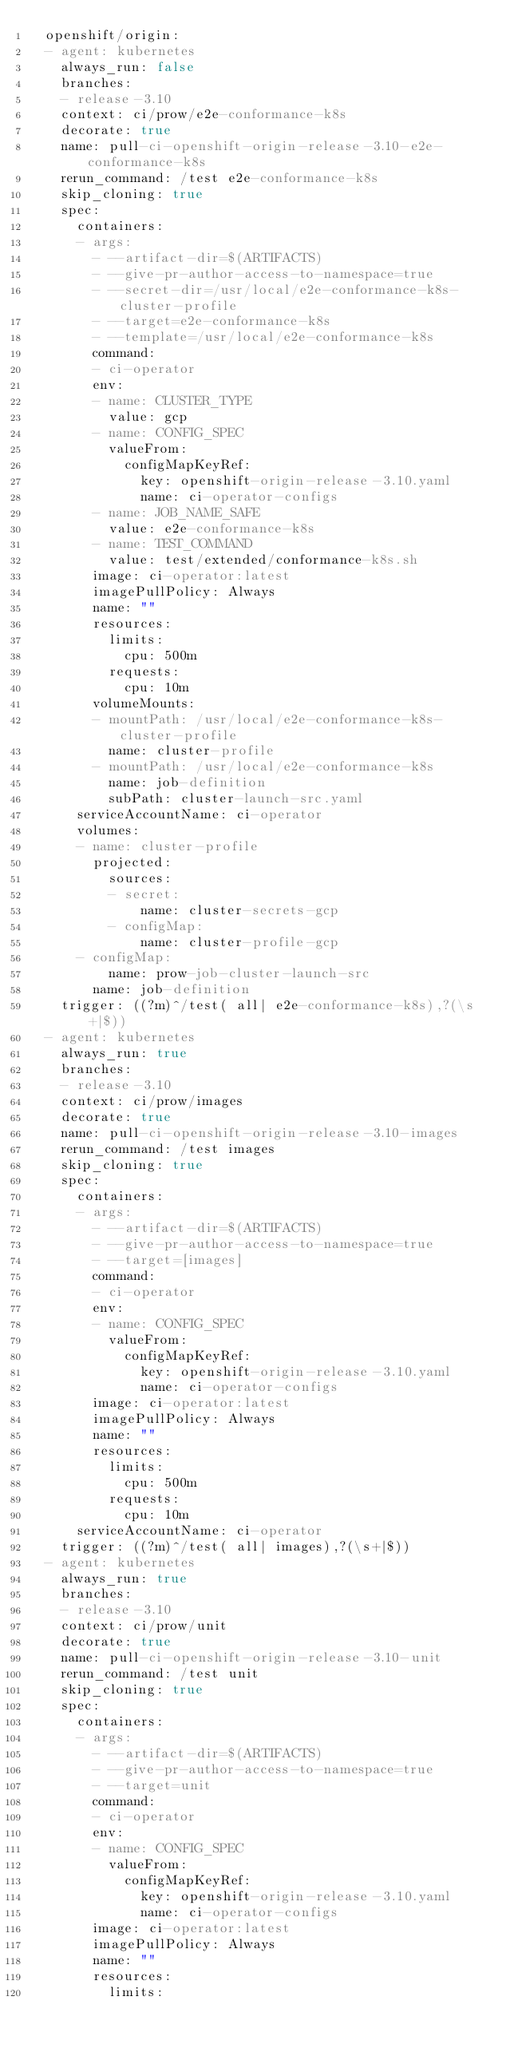<code> <loc_0><loc_0><loc_500><loc_500><_YAML_>  openshift/origin:
  - agent: kubernetes
    always_run: false
    branches:
    - release-3.10
    context: ci/prow/e2e-conformance-k8s
    decorate: true
    name: pull-ci-openshift-origin-release-3.10-e2e-conformance-k8s
    rerun_command: /test e2e-conformance-k8s
    skip_cloning: true
    spec:
      containers:
      - args:
        - --artifact-dir=$(ARTIFACTS)
        - --give-pr-author-access-to-namespace=true
        - --secret-dir=/usr/local/e2e-conformance-k8s-cluster-profile
        - --target=e2e-conformance-k8s
        - --template=/usr/local/e2e-conformance-k8s
        command:
        - ci-operator
        env:
        - name: CLUSTER_TYPE
          value: gcp
        - name: CONFIG_SPEC
          valueFrom:
            configMapKeyRef:
              key: openshift-origin-release-3.10.yaml
              name: ci-operator-configs
        - name: JOB_NAME_SAFE
          value: e2e-conformance-k8s
        - name: TEST_COMMAND
          value: test/extended/conformance-k8s.sh
        image: ci-operator:latest
        imagePullPolicy: Always
        name: ""
        resources:
          limits:
            cpu: 500m
          requests:
            cpu: 10m
        volumeMounts:
        - mountPath: /usr/local/e2e-conformance-k8s-cluster-profile
          name: cluster-profile
        - mountPath: /usr/local/e2e-conformance-k8s
          name: job-definition
          subPath: cluster-launch-src.yaml
      serviceAccountName: ci-operator
      volumes:
      - name: cluster-profile
        projected:
          sources:
          - secret:
              name: cluster-secrets-gcp
          - configMap:
              name: cluster-profile-gcp
      - configMap:
          name: prow-job-cluster-launch-src
        name: job-definition
    trigger: ((?m)^/test( all| e2e-conformance-k8s),?(\s+|$))
  - agent: kubernetes
    always_run: true
    branches:
    - release-3.10
    context: ci/prow/images
    decorate: true
    name: pull-ci-openshift-origin-release-3.10-images
    rerun_command: /test images
    skip_cloning: true
    spec:
      containers:
      - args:
        - --artifact-dir=$(ARTIFACTS)
        - --give-pr-author-access-to-namespace=true
        - --target=[images]
        command:
        - ci-operator
        env:
        - name: CONFIG_SPEC
          valueFrom:
            configMapKeyRef:
              key: openshift-origin-release-3.10.yaml
              name: ci-operator-configs
        image: ci-operator:latest
        imagePullPolicy: Always
        name: ""
        resources:
          limits:
            cpu: 500m
          requests:
            cpu: 10m
      serviceAccountName: ci-operator
    trigger: ((?m)^/test( all| images),?(\s+|$))
  - agent: kubernetes
    always_run: true
    branches:
    - release-3.10
    context: ci/prow/unit
    decorate: true
    name: pull-ci-openshift-origin-release-3.10-unit
    rerun_command: /test unit
    skip_cloning: true
    spec:
      containers:
      - args:
        - --artifact-dir=$(ARTIFACTS)
        - --give-pr-author-access-to-namespace=true
        - --target=unit
        command:
        - ci-operator
        env:
        - name: CONFIG_SPEC
          valueFrom:
            configMapKeyRef:
              key: openshift-origin-release-3.10.yaml
              name: ci-operator-configs
        image: ci-operator:latest
        imagePullPolicy: Always
        name: ""
        resources:
          limits:</code> 